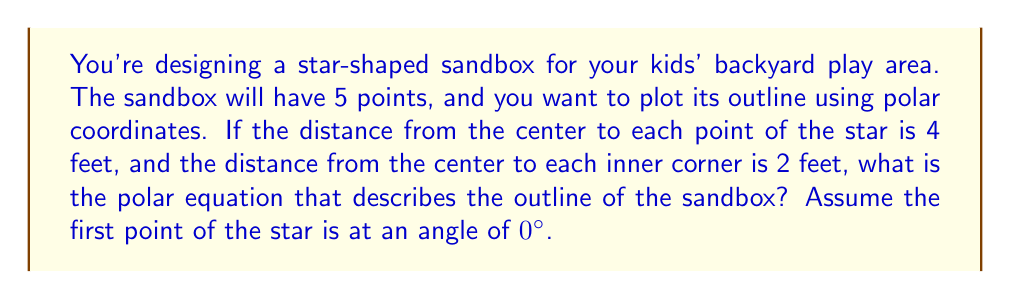Show me your answer to this math problem. To find the polar equation for the star-shaped sandbox, we need to follow these steps:

1. Recognize that the star has 5 points, so it repeats every 72° (360° / 5 = 72°).

2. The radius alternates between 4 feet (at the points) and 2 feet (at the inner corners).

3. We can use a cosine function to create this alternating pattern. The general form of the equation will be:

   $$ r = a - b \cos(5\theta) $$

   Where $a$ is the average of the maximum and minimum radii, and $b$ is half their difference.

4. Calculate $a$ and $b$:
   $$ a = \frac{4 + 2}{2} = 3 $$
   $$ b = \frac{4 - 2}{2} = 1 $$

5. Substitute these values into the general equation:

   $$ r = 3 - \cos(5\theta) $$

6. We multiply $\theta$ by 5 inside the cosine function to make the pattern repeat 5 times in a full 360° rotation.

This equation will produce a 5-pointed star shape with the specified dimensions when plotted in polar coordinates.

[asy]
import graph;
size(200);

real r(real theta) {
  return 3 - cos(5*theta);
}

polarplot(r, (0,2pi), red);
dot((4,0), blue);
dot((2,72*pi/180), blue);
label("4 ft", (4,0), E);
label("2 ft", (2,72*pi/180), NE);
label("0°", (4.5,0), E);
label("72°", (2.5,72*pi/180), NE);
[/asy]
Answer: $$ r = 3 - \cos(5\theta) $$ 